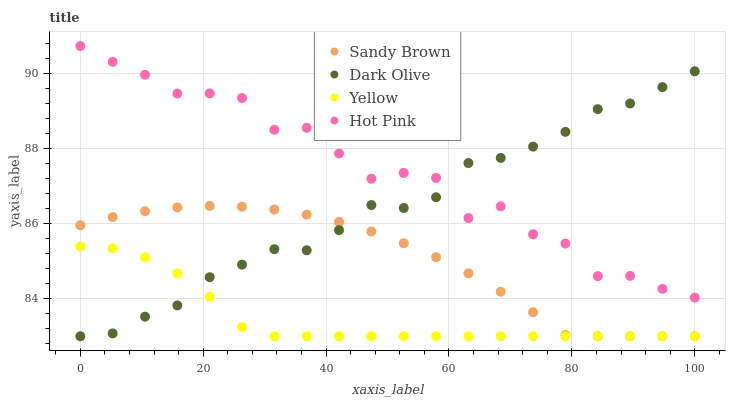Does Yellow have the minimum area under the curve?
Answer yes or no. Yes. Does Hot Pink have the maximum area under the curve?
Answer yes or no. Yes. Does Sandy Brown have the minimum area under the curve?
Answer yes or no. No. Does Sandy Brown have the maximum area under the curve?
Answer yes or no. No. Is Sandy Brown the smoothest?
Answer yes or no. Yes. Is Hot Pink the roughest?
Answer yes or no. Yes. Is Yellow the smoothest?
Answer yes or no. No. Is Yellow the roughest?
Answer yes or no. No. Does Dark Olive have the lowest value?
Answer yes or no. Yes. Does Hot Pink have the lowest value?
Answer yes or no. No. Does Hot Pink have the highest value?
Answer yes or no. Yes. Does Sandy Brown have the highest value?
Answer yes or no. No. Is Sandy Brown less than Hot Pink?
Answer yes or no. Yes. Is Hot Pink greater than Yellow?
Answer yes or no. Yes. Does Dark Olive intersect Hot Pink?
Answer yes or no. Yes. Is Dark Olive less than Hot Pink?
Answer yes or no. No. Is Dark Olive greater than Hot Pink?
Answer yes or no. No. Does Sandy Brown intersect Hot Pink?
Answer yes or no. No. 